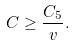Convert formula to latex. <formula><loc_0><loc_0><loc_500><loc_500>C \geq \frac { C _ { 5 } } { v } .</formula> 